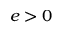Convert formula to latex. <formula><loc_0><loc_0><loc_500><loc_500>e > 0</formula> 